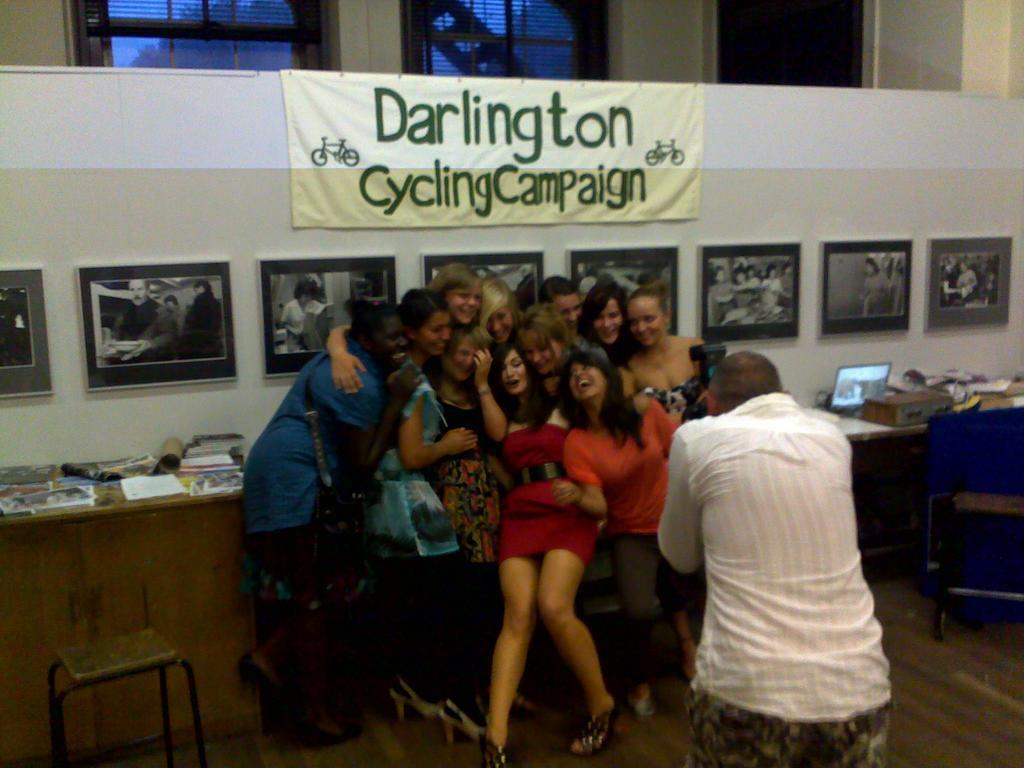In one or two sentences, can you explain what this image depicts? There are people and this person holding a camera. We can see screen and objects on the table. We can see banner and frames on the wall and windows. 